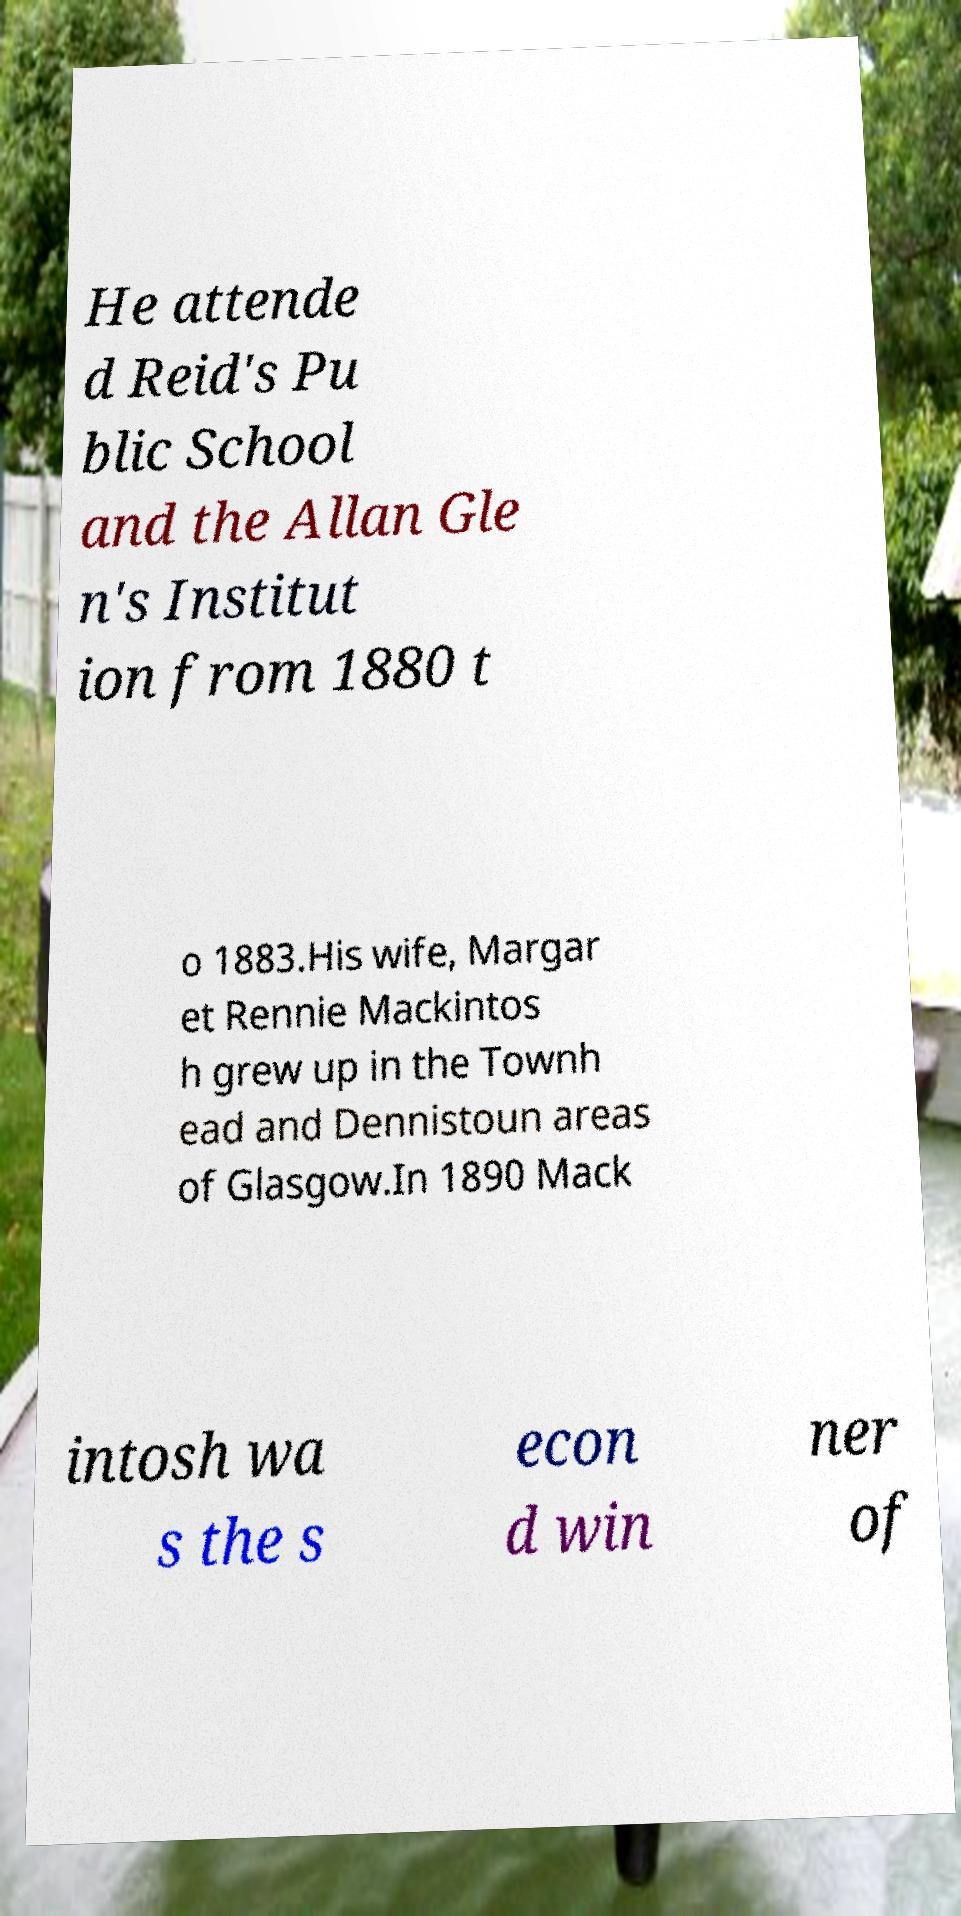What messages or text are displayed in this image? I need them in a readable, typed format. He attende d Reid's Pu blic School and the Allan Gle n's Institut ion from 1880 t o 1883.His wife, Margar et Rennie Mackintos h grew up in the Townh ead and Dennistoun areas of Glasgow.In 1890 Mack intosh wa s the s econ d win ner of 